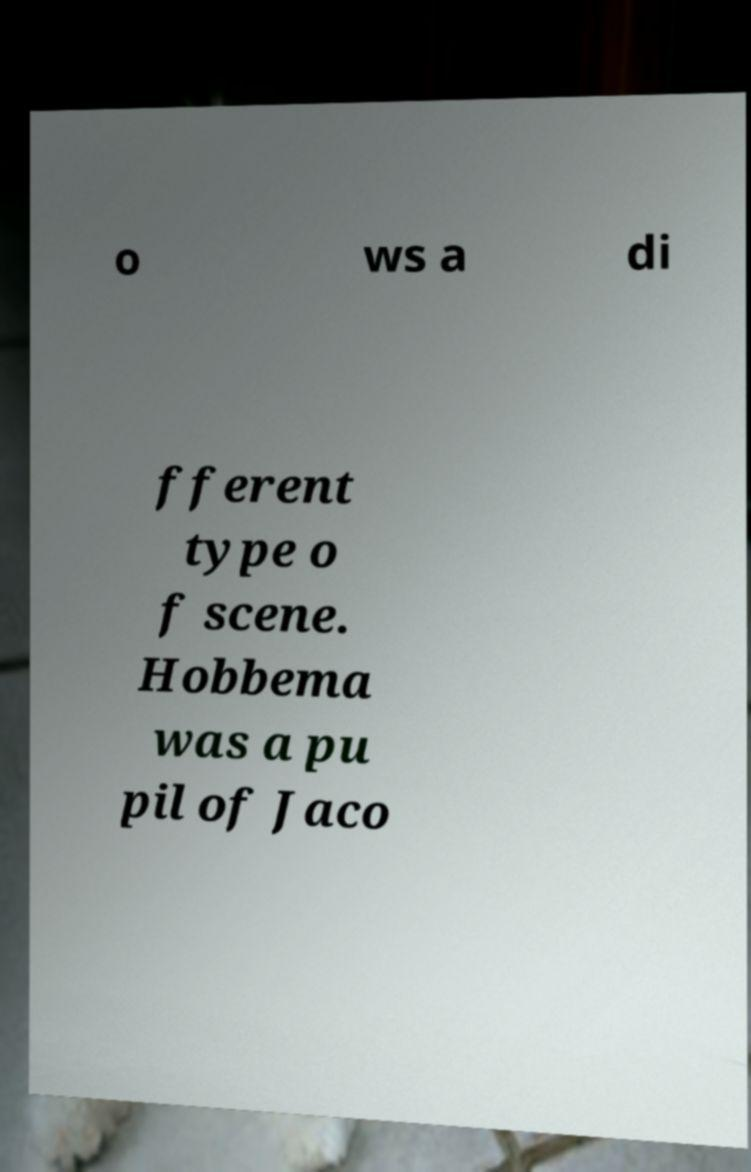Please identify and transcribe the text found in this image. o ws a di fferent type o f scene. Hobbema was a pu pil of Jaco 